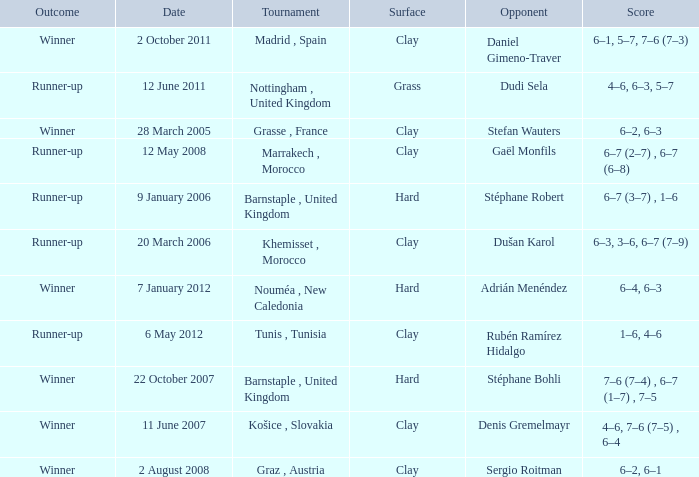What is the surface of the tournament with a runner-up outcome and dudi sela as the opponent? Grass. 